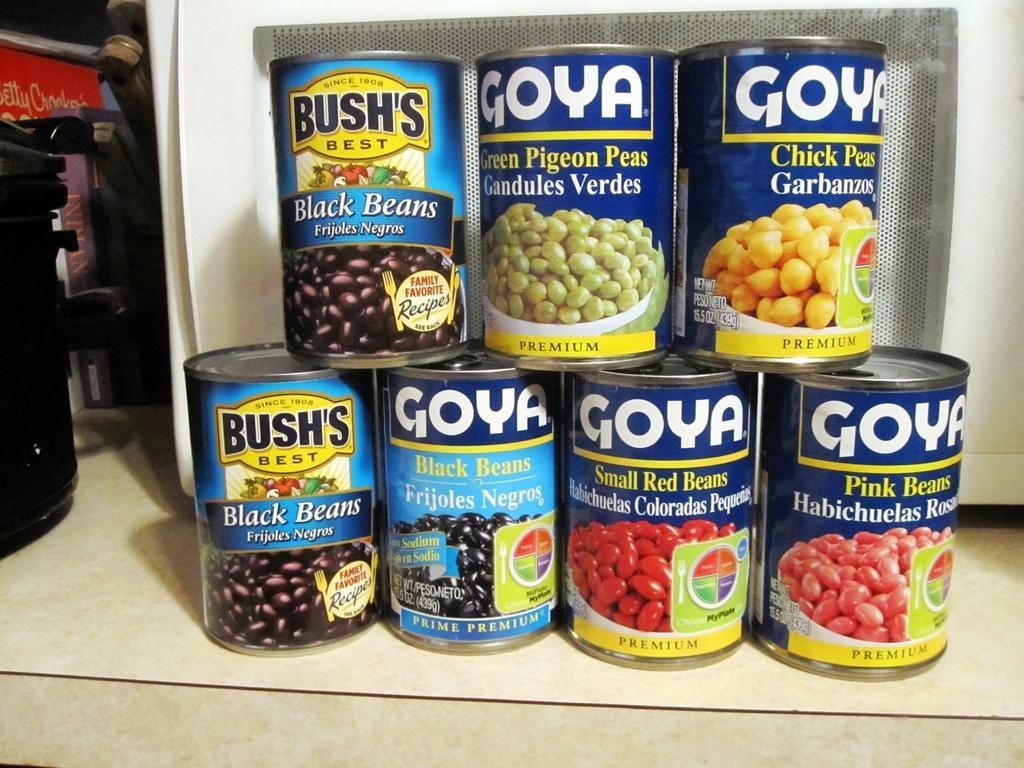In one or two sentences, can you explain what this image depicts? Here I can see few containers which are placed on a table. On the left side, I can see a black color object. At the back of these containers I can see a machine which is in white color. 